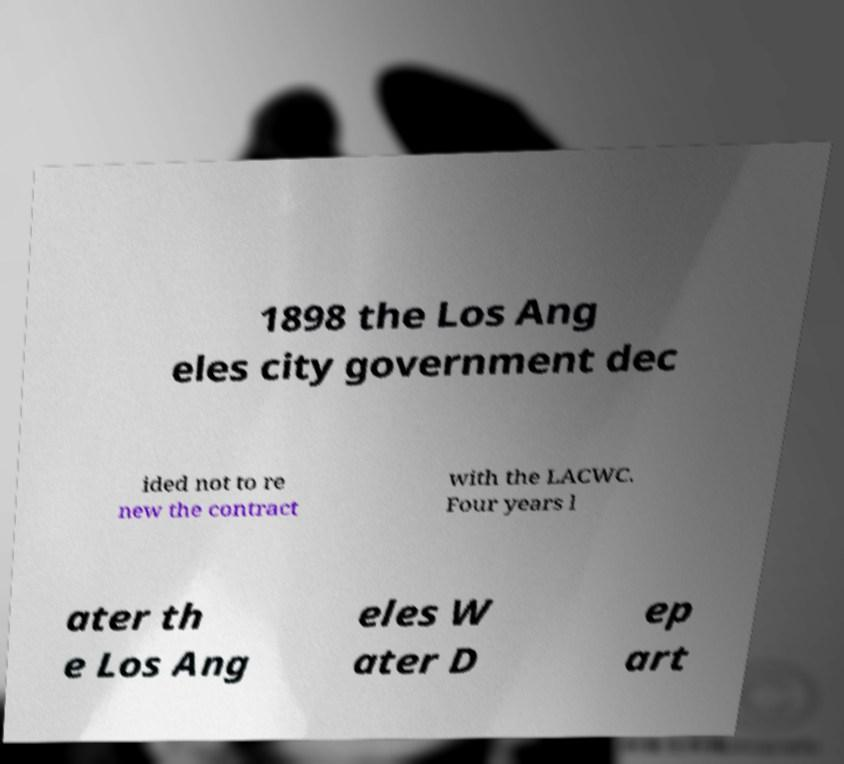Please read and relay the text visible in this image. What does it say? 1898 the Los Ang eles city government dec ided not to re new the contract with the LACWC. Four years l ater th e Los Ang eles W ater D ep art 